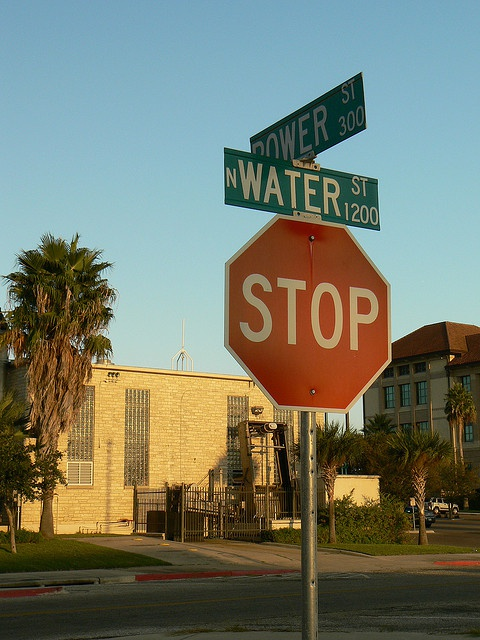Describe the objects in this image and their specific colors. I can see stop sign in lightblue, maroon, brown, and tan tones, car in lightblue, black, tan, gray, and olive tones, and car in lightblue, black, gray, and darkgreen tones in this image. 